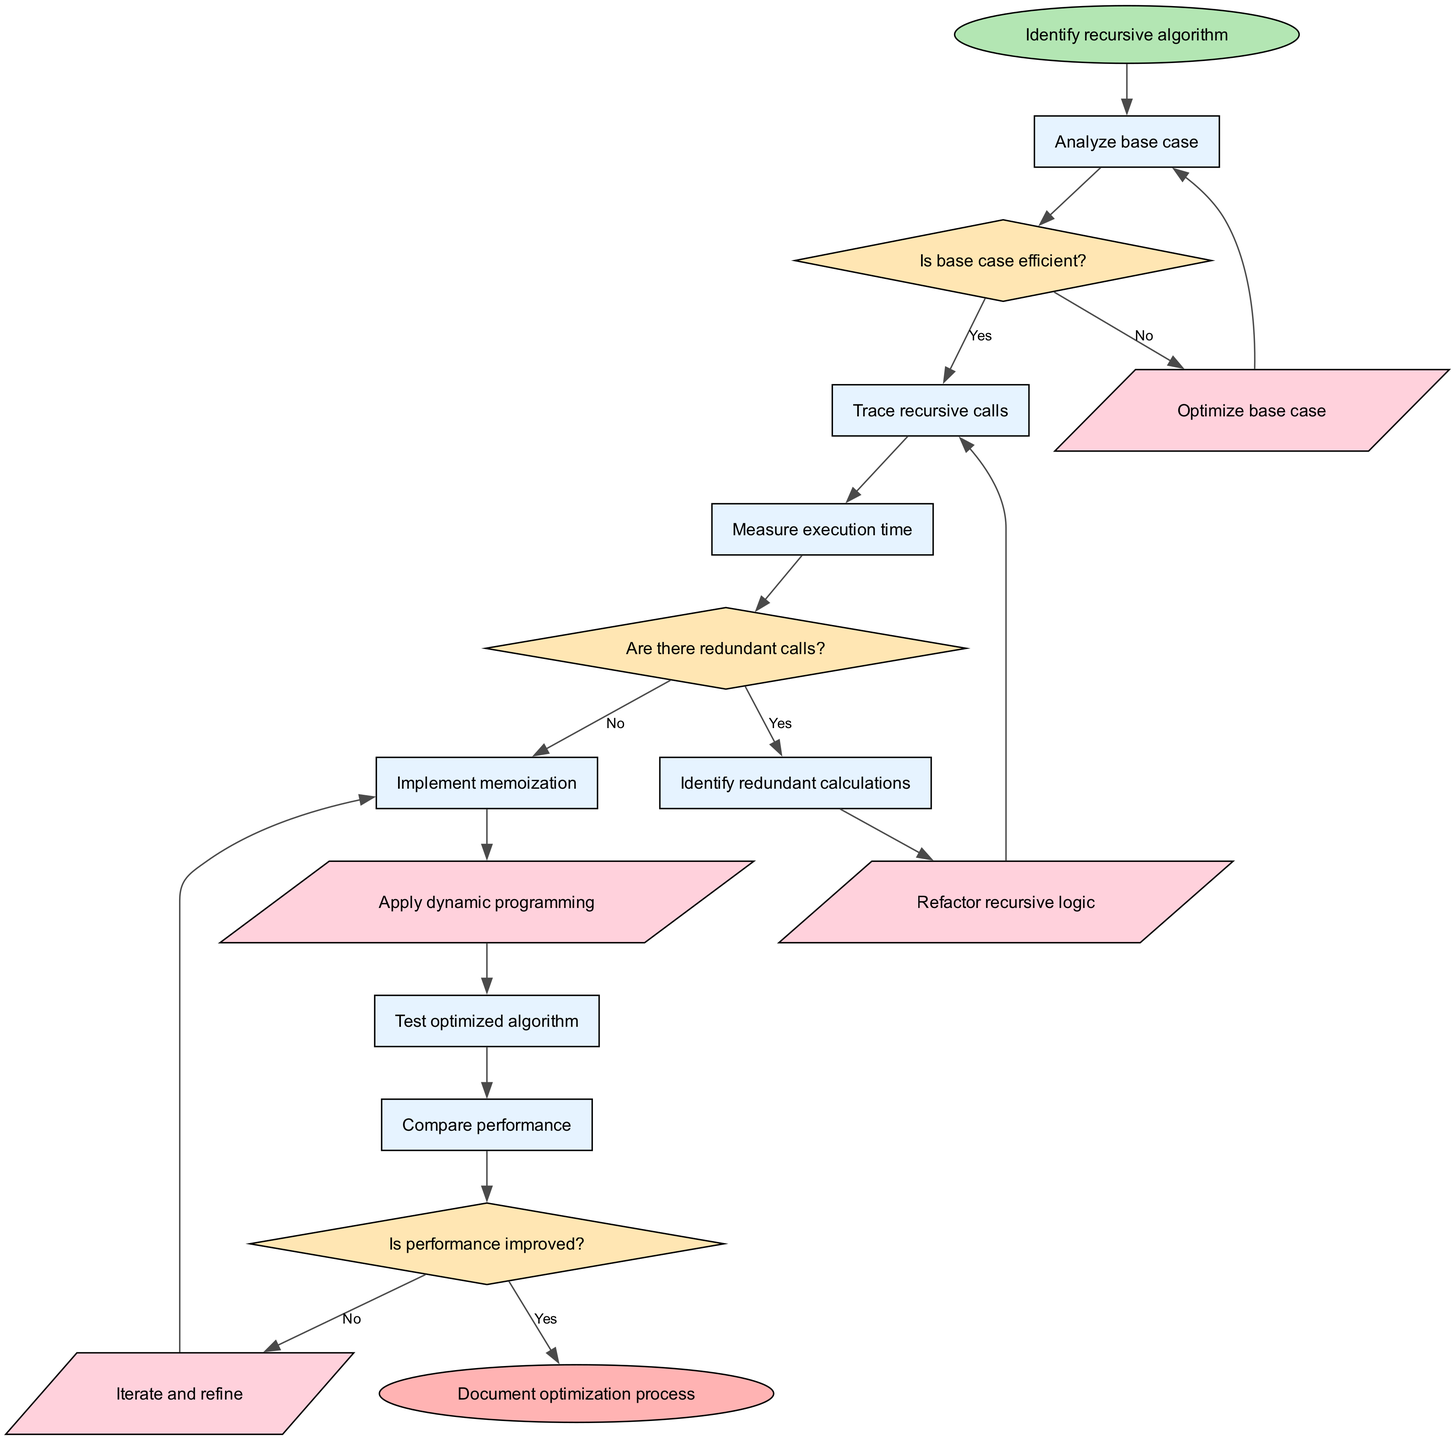What is the starting point of the flowchart? The starting point is labeled as "Identify recursive algorithm". It's the first node represented by the ellipse shape in the diagram, indicating where the process begins.
Answer: Identify recursive algorithm How many process nodes are present in the flowchart? There are six process nodes in the diagram: "Analyze base case", "Trace recursive calls", "Measure execution time", "Identify redundant calculations", "Implement memoization", and "Test optimized algorithm". Thus, the total count is six.
Answer: 6 What decision follows the "Analyze base case" node? The decision that follows the "Analyze base case" node is titled "Is base case efficient?". This can be identified by tracing the edges leading out of the node.
Answer: Is base case efficient? What happens if the answer to "Are there redundant calls?" is yes? If the answer to "Are there redundant calls?" is yes, the flowchart indicates that the next step is to "Identify redundant calculations", allowing the algorithm to optimize its performance by addressing redundancy.
Answer: Identify redundant calculations How is the optimization process documented? The optimization process is documented at the end of the flowchart, which is the last node labeled "Document optimization process". This indicates the concluding action of the algorithm optimization procedures.
Answer: Document optimization process What is the relationship between "Test optimized algorithm" and "Compare performance"? "Test optimized algorithm" is the node directly preceding "Compare performance". Once the algorithm is tested, the next action is to compare its performance, establishing a sequential flow of actions.
Answer: Directly precedes What edge represents the action to improve the base case? The edge that represents the action to improve the base case is labeled "Optimize base case". This edge connects the decision regarding base case efficiency to the next step in the optimization process.
Answer: Optimize base case If the performance is not improved, what process node is revisited next? If the performance is not improved, the flowchart suggests revisiting "Implement memoization" as indicated by the edge that loops back to that process node after the decision regarding performance improvement.
Answer: Implement memoization What type of decision is "Is performance improved?" "Is performance improved?" is a decision node characterized by a diamond shape and involves assessing the outcome of prior actions pertaining to the optimized algorithm's performance.
Answer: Decision node 